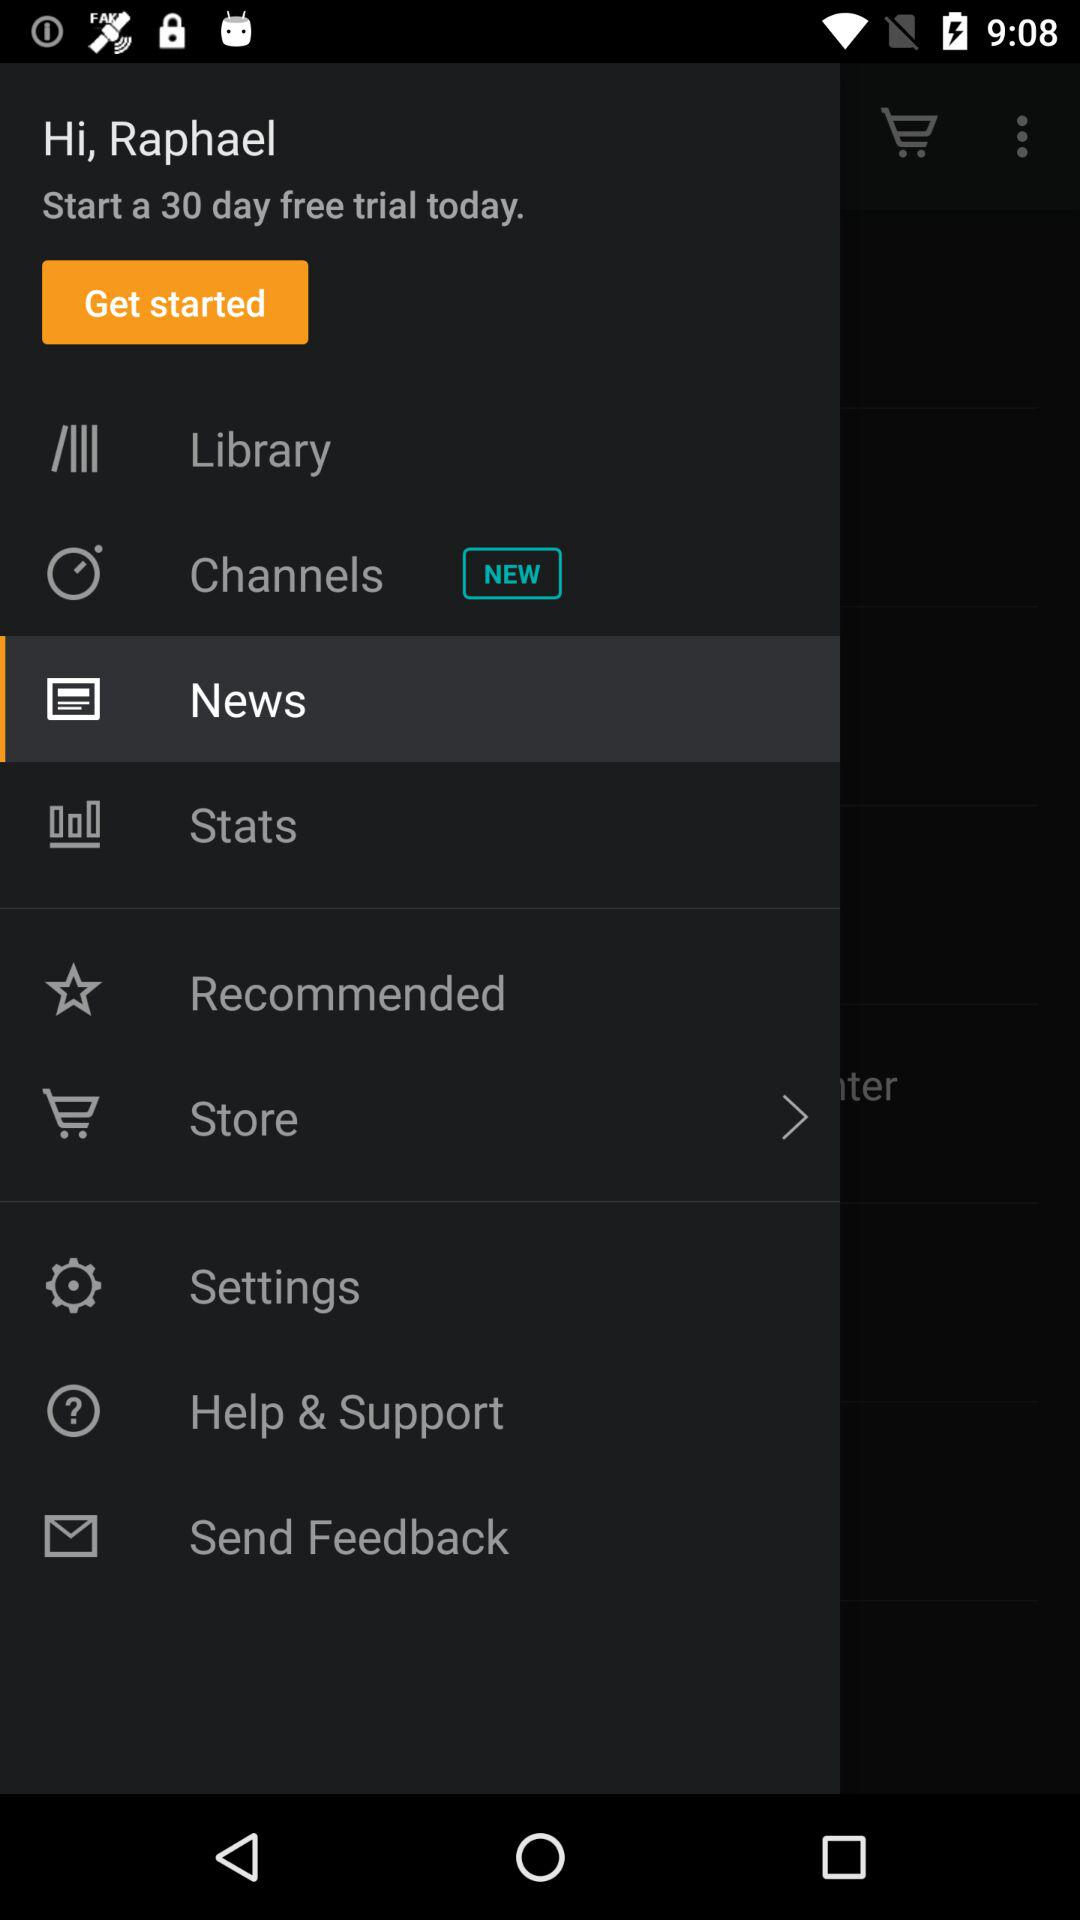For how many days is the free trial? The free trial is for 30 days. 